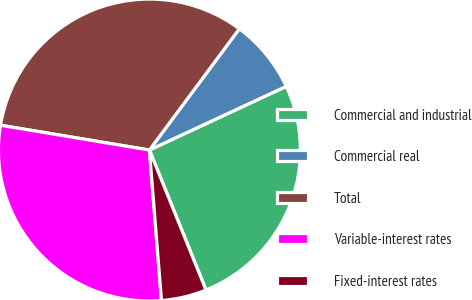Convert chart to OTSL. <chart><loc_0><loc_0><loc_500><loc_500><pie_chart><fcel>Commercial and industrial<fcel>Commercial real<fcel>Total<fcel>Variable-interest rates<fcel>Fixed-interest rates<nl><fcel>25.82%<fcel>7.91%<fcel>32.53%<fcel>28.9%<fcel>4.84%<nl></chart> 